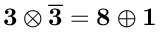<formula> <loc_0><loc_0><loc_500><loc_500>3 \otimes \overline { 3 } = 8 \oplus 1</formula> 